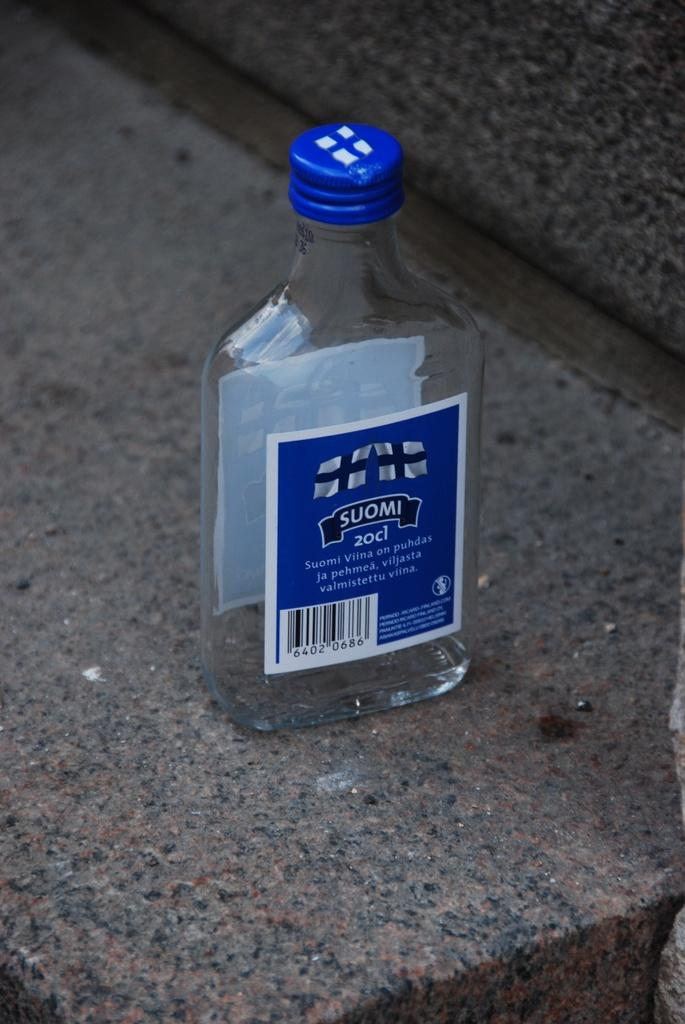<image>
Render a clear and concise summary of the photo. The label on the glass bottle is Suomi 